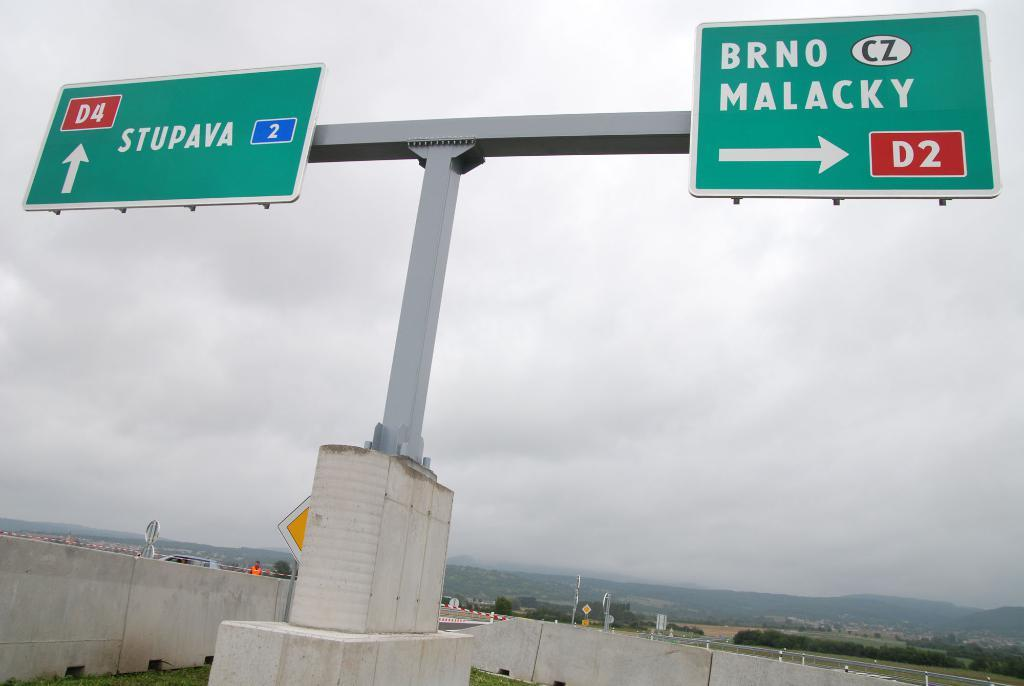<image>
Summarize the visual content of the image. A street sign that shows that Brno Malacky is to the right. 